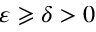Convert formula to latex. <formula><loc_0><loc_0><loc_500><loc_500>\varepsilon \geqslant \delta > 0</formula> 